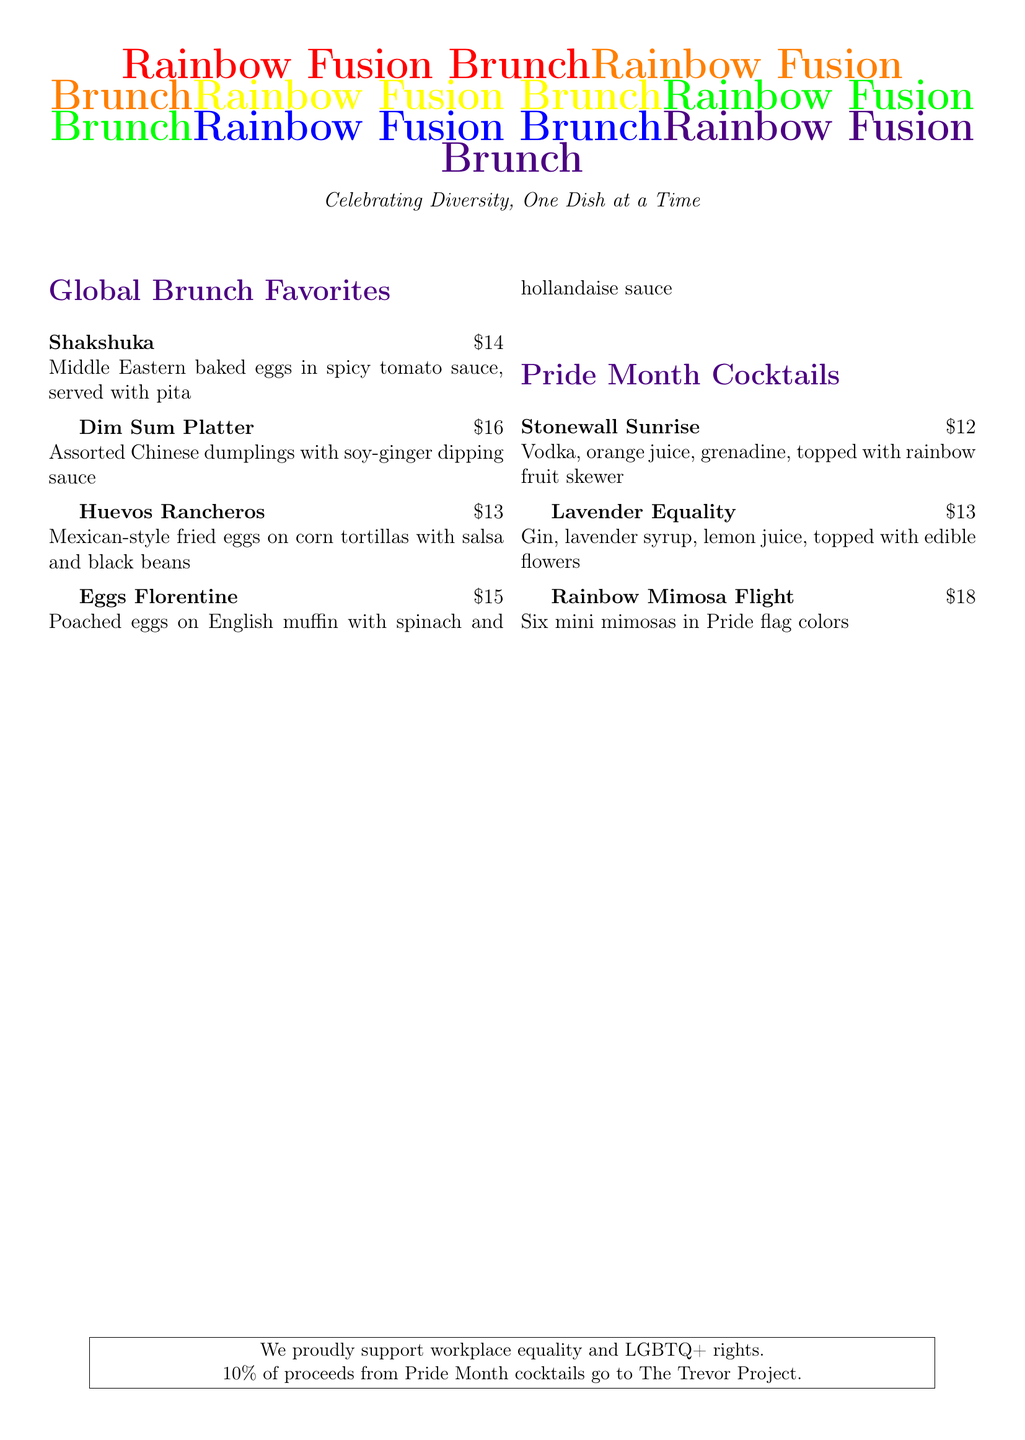What is the price of Shakshuka? The price of Shakshuka is listed under the Global Brunch Favorites section.
Answer: $14 How many mini mimosas are included in the Rainbow Mimosa Flight? The Rainbow Mimosa Flight includes six mini mimosas in Pride flag colors.
Answer: Six What is the primary ingredient in Lavender Equality? Lavender Equality features gin and is flavored with lavender syrup.
Answer: Gin Which dish is inspired by Mexican cuisine? Huevos Rancheros is specifically mentioned as a Mexican-style dish on the menu.
Answer: Huevos Rancheros What percentage of proceeds from Pride Month cocktails goes to The Trevor Project? The document states that 10% of proceeds from Pride Month cocktails are donated.
Answer: 10% What sauce is served with the Dim Sum Platter? The Dim Sum Platter is served with a soy-ginger dipping sauce, as mentioned in the description.
Answer: Soy-ginger dipping sauce Which cocktail is topped with edible flowers? The Lavender Equality cocktail is topped with edible flowers according to the menu.
Answer: Lavender Equality How are the poached eggs in Eggs Florentine served? The Eggs Florentine are served on English muffins, which is specified in the dish description.
Answer: On English muffin 